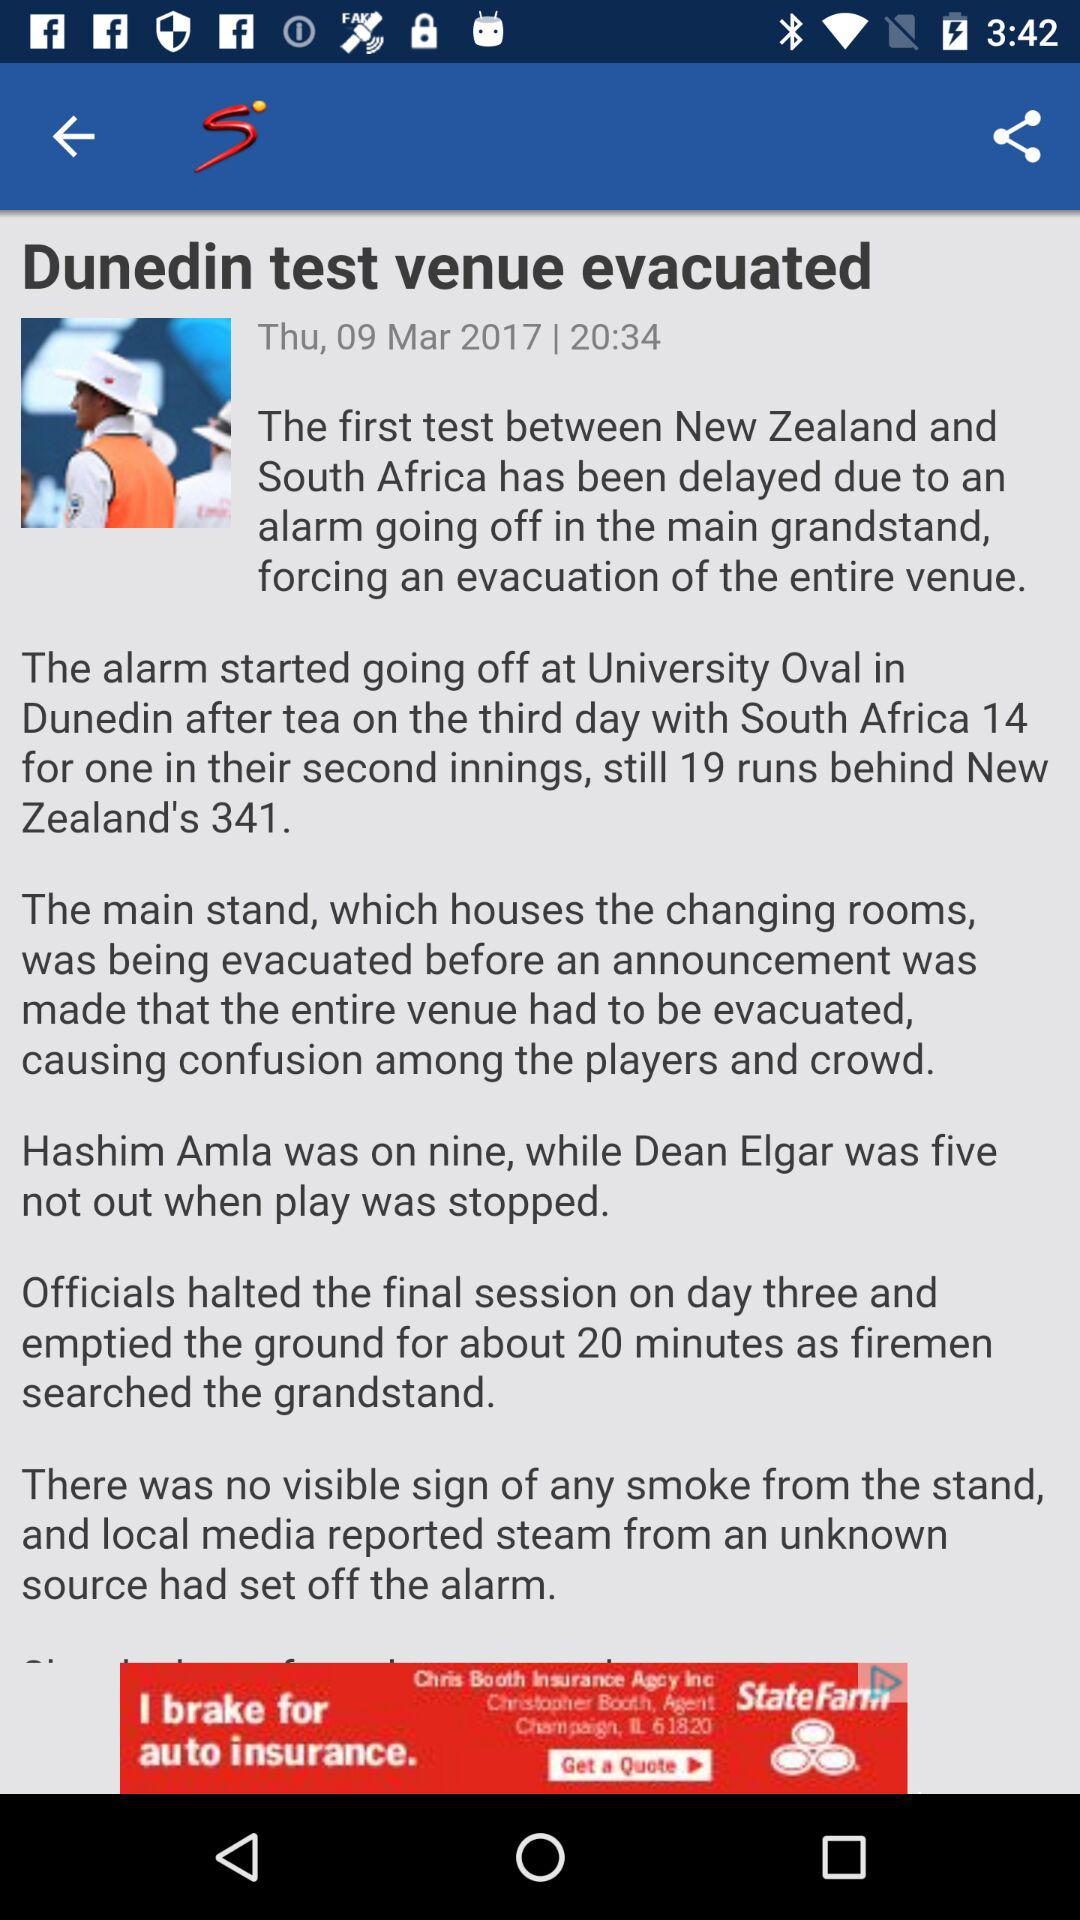When was the article posted? The article was posted on Thursday, March 09, 2017 at 20:34. 